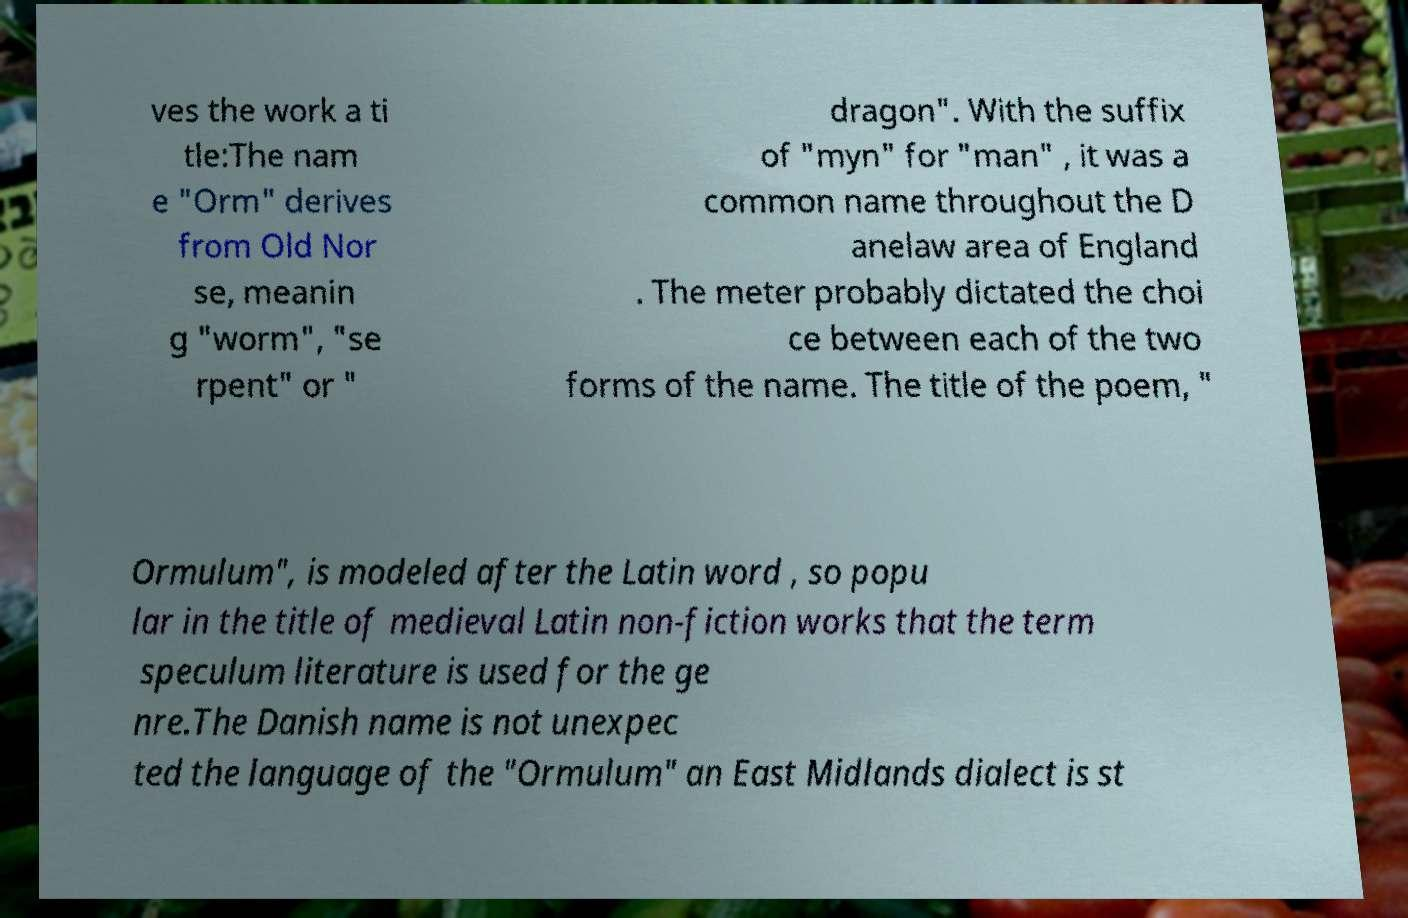Please identify and transcribe the text found in this image. ves the work a ti tle:The nam e "Orm" derives from Old Nor se, meanin g "worm", "se rpent" or " dragon". With the suffix of "myn" for "man" , it was a common name throughout the D anelaw area of England . The meter probably dictated the choi ce between each of the two forms of the name. The title of the poem, " Ormulum", is modeled after the Latin word , so popu lar in the title of medieval Latin non-fiction works that the term speculum literature is used for the ge nre.The Danish name is not unexpec ted the language of the "Ormulum" an East Midlands dialect is st 